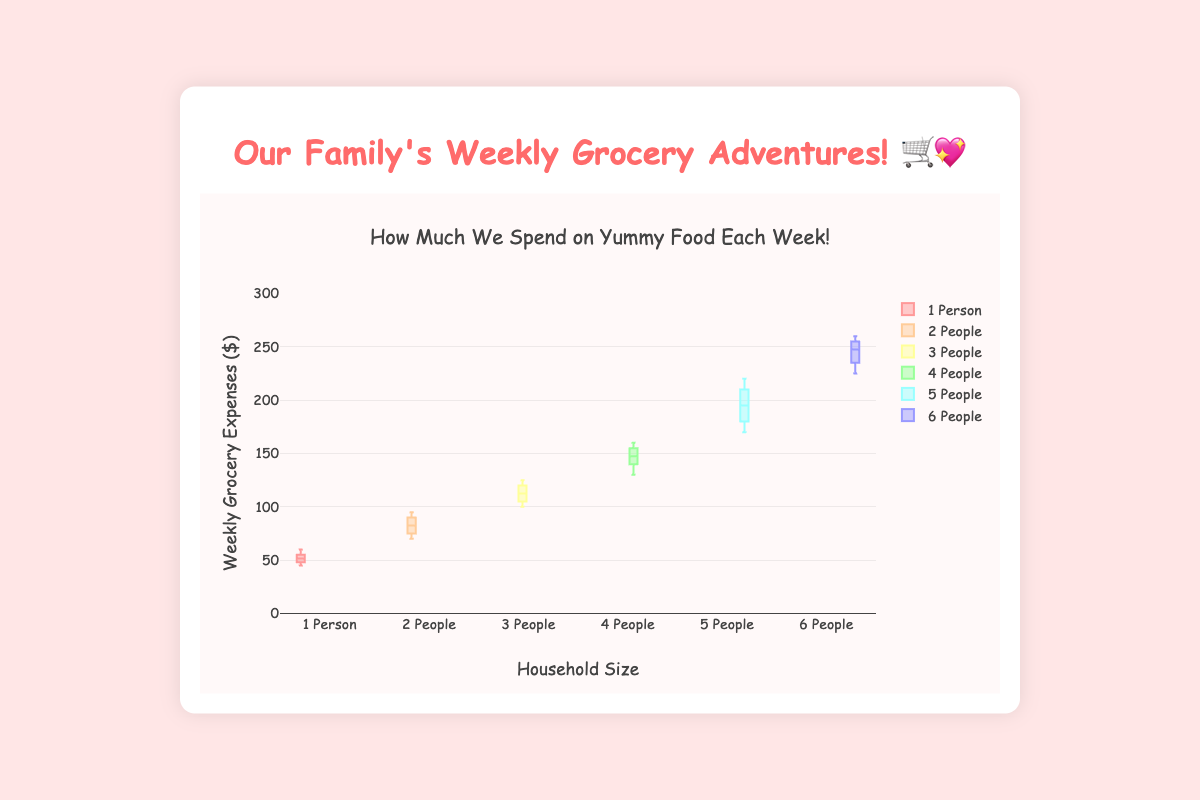What is the title of the figure? The title is displayed at the top of the figure. It reads "How Much We Spend on Yummy Food Each Week!".
Answer: How Much We Spend on Yummy Food Each Week! What does the y-axis represent? The y-axis is labeled "Weekly Grocery Expenses ($)", indicating it represents the dollar amount spent on groceries each week.
Answer: Weekly Grocery Expenses ($) How many household size categories are displayed in the figure? The x-axis presents different categories representing the household sizes. There are six categories shown: "1 Person," "2 People," "3 People," "4 People," "5 People," and "6 People."
Answer: Six Which household size has the highest median weekly grocery expenditure? The median lines within the boxes indicate the middle value. For household size 6, the median is highest compared to all other household sizes.
Answer: Household size 6 What is the range of weekly grocery expenditures for a household of 4 people? The range is determined by the difference between the maximum and minimum values shown by the top and bottom of the box, respectively. For a household of 4 people, this is from 130 (min) to 160 (max). The range is 160 - 130 = 30.
Answer: $30 How do the median weekly grocery expenditures compare between a household of 2 people and a household of 3 people? The median line for a household of 2 people and 3 people should be compared. The median for 2 people is slightly lower than the median for 3 people.
Answer: Lower for 2 people Which household size category shows the greatest variation in weekly grocery expenditures? The variation can be observed by looking at the height of the boxes and whiskers. Household size 6 shows the greatest spread from minimum to maximum values, indicating the largest variation.
Answer: Household size 6 What is the interquartile range (IQR) for the household size of 1 person? The IQR is the range between the first quartile (25th percentile) and third quartile (75th percentile). For household size 1, the box spans from about 48 to 55. Therefore, IQR = 55 - 48 = 7.
Answer: $7 How do the weekly expenditures for grocery change with increasing household size? Observing the medians and boxes, the weekly grocery expenditures progressively increase as the household size increases from 1 person to 6 people.
Answer: Increases Which household size has the smallest overall weekly grocery expenditure? By comparing the minimum points across all household sizes, the smallest expenditure is seen in the household size of 1 person.
Answer: Household size 1 